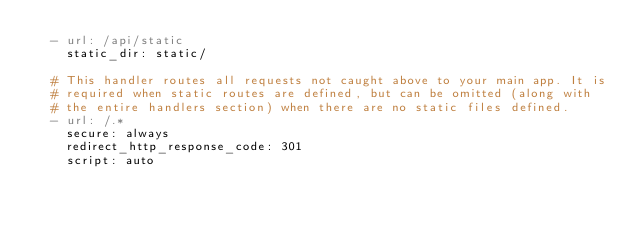Convert code to text. <code><loc_0><loc_0><loc_500><loc_500><_YAML_>  - url: /api/static
    static_dir: static/

  # This handler routes all requests not caught above to your main app. It is
  # required when static routes are defined, but can be omitted (along with
  # the entire handlers section) when there are no static files defined.
  - url: /.*
    secure: always
    redirect_http_response_code: 301
    script: auto
</code> 